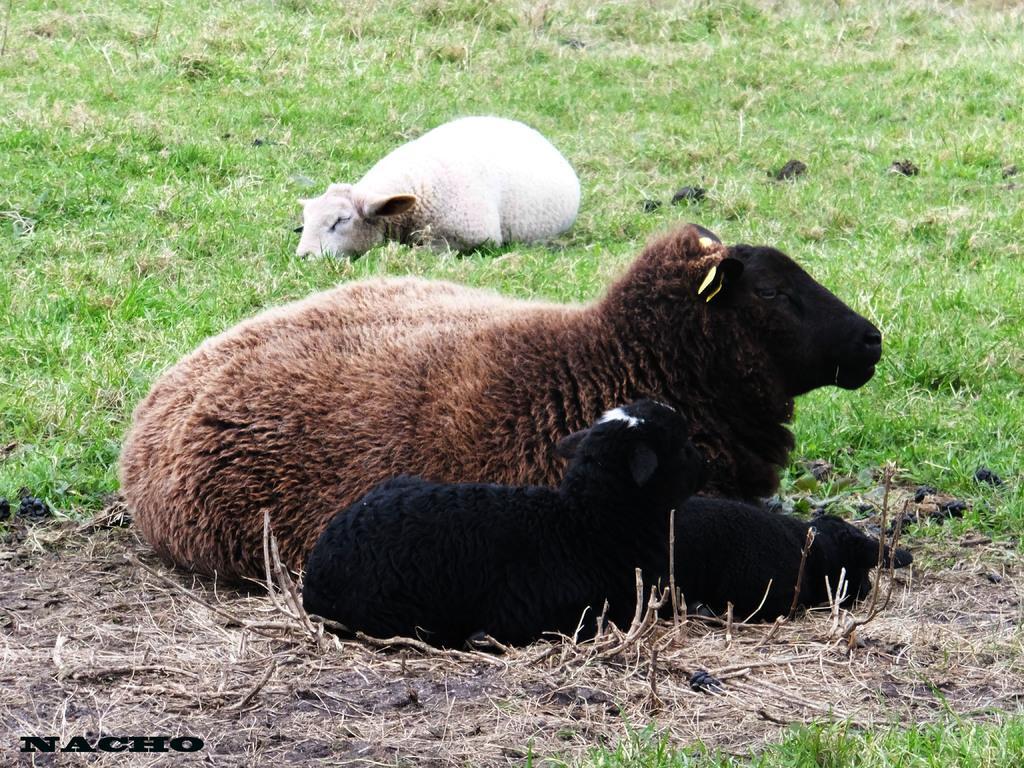How would you summarize this image in a sentence or two? There are two sheep and beside the second sheep there are two baby sheep,these are laying on the grass. 